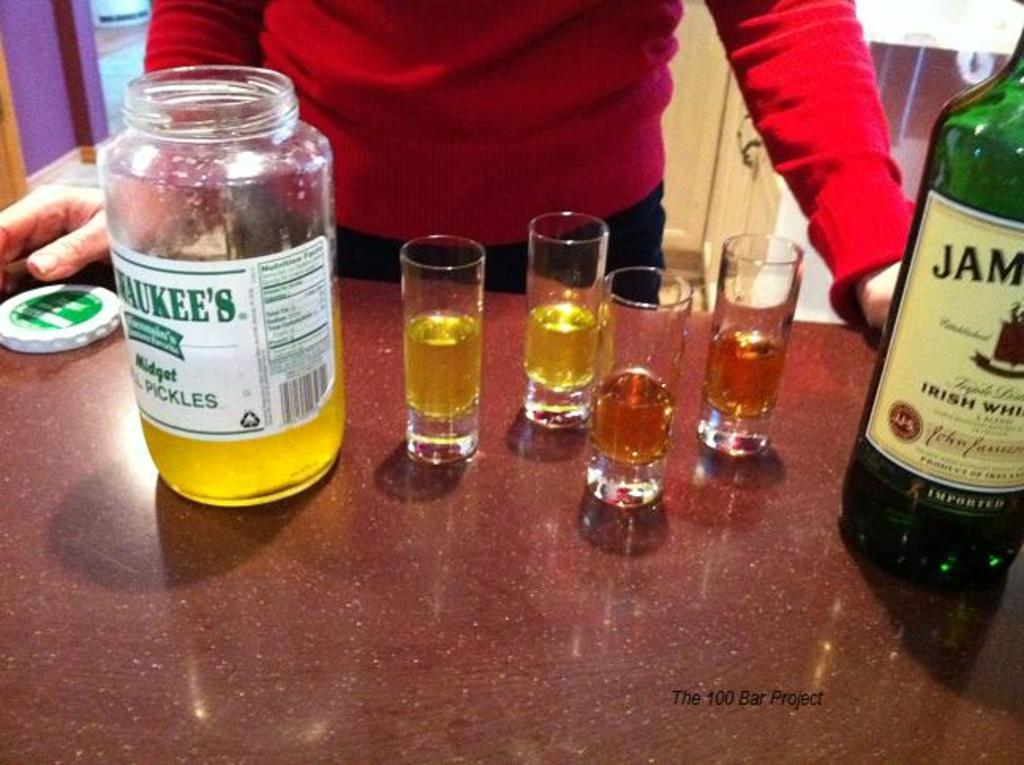<image>
Offer a succinct explanation of the picture presented. an open jar of pickle juice with shot glasses next to it 